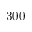<formula> <loc_0><loc_0><loc_500><loc_500>3 0 0</formula> 